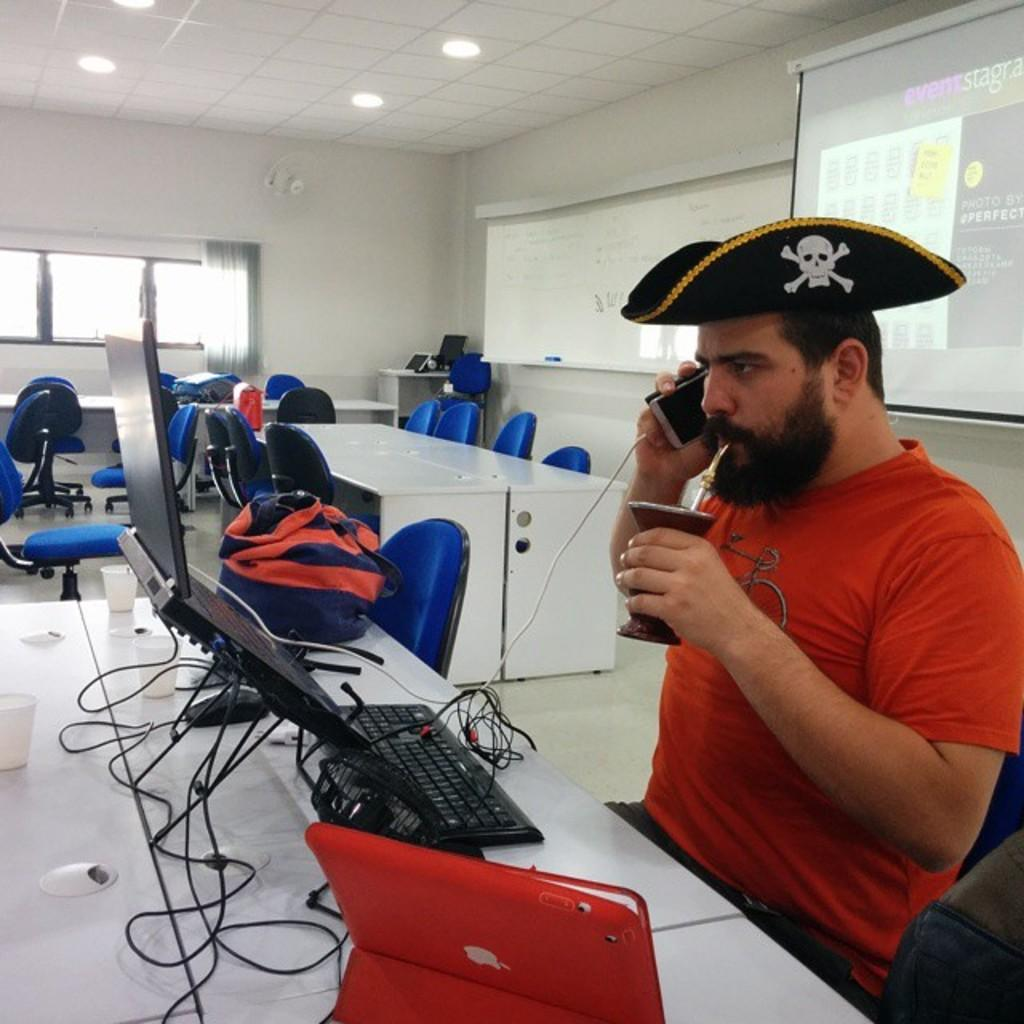What is the person in the image doing? The person is sitting in front of a system. What object is the person holding? The person is holding a mobile. What can be seen in the background of the image? There are lights and a window in the background. How many cherries are on the table in the image? There are no cherries present in the image. What type of box is being used by the person in the image? There is no box visible in the image. 